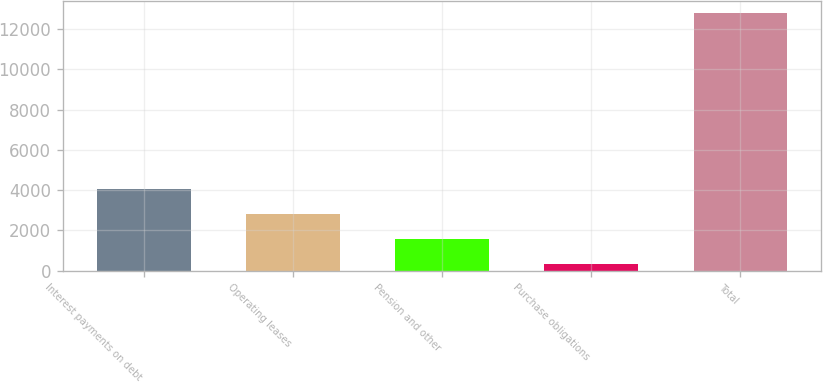<chart> <loc_0><loc_0><loc_500><loc_500><bar_chart><fcel>Interest payments on debt<fcel>Operating leases<fcel>Pension and other<fcel>Purchase obligations<fcel>Total<nl><fcel>4069.9<fcel>2826.6<fcel>1583.3<fcel>340<fcel>12773<nl></chart> 